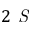<formula> <loc_0><loc_0><loc_500><loc_500>2 S</formula> 